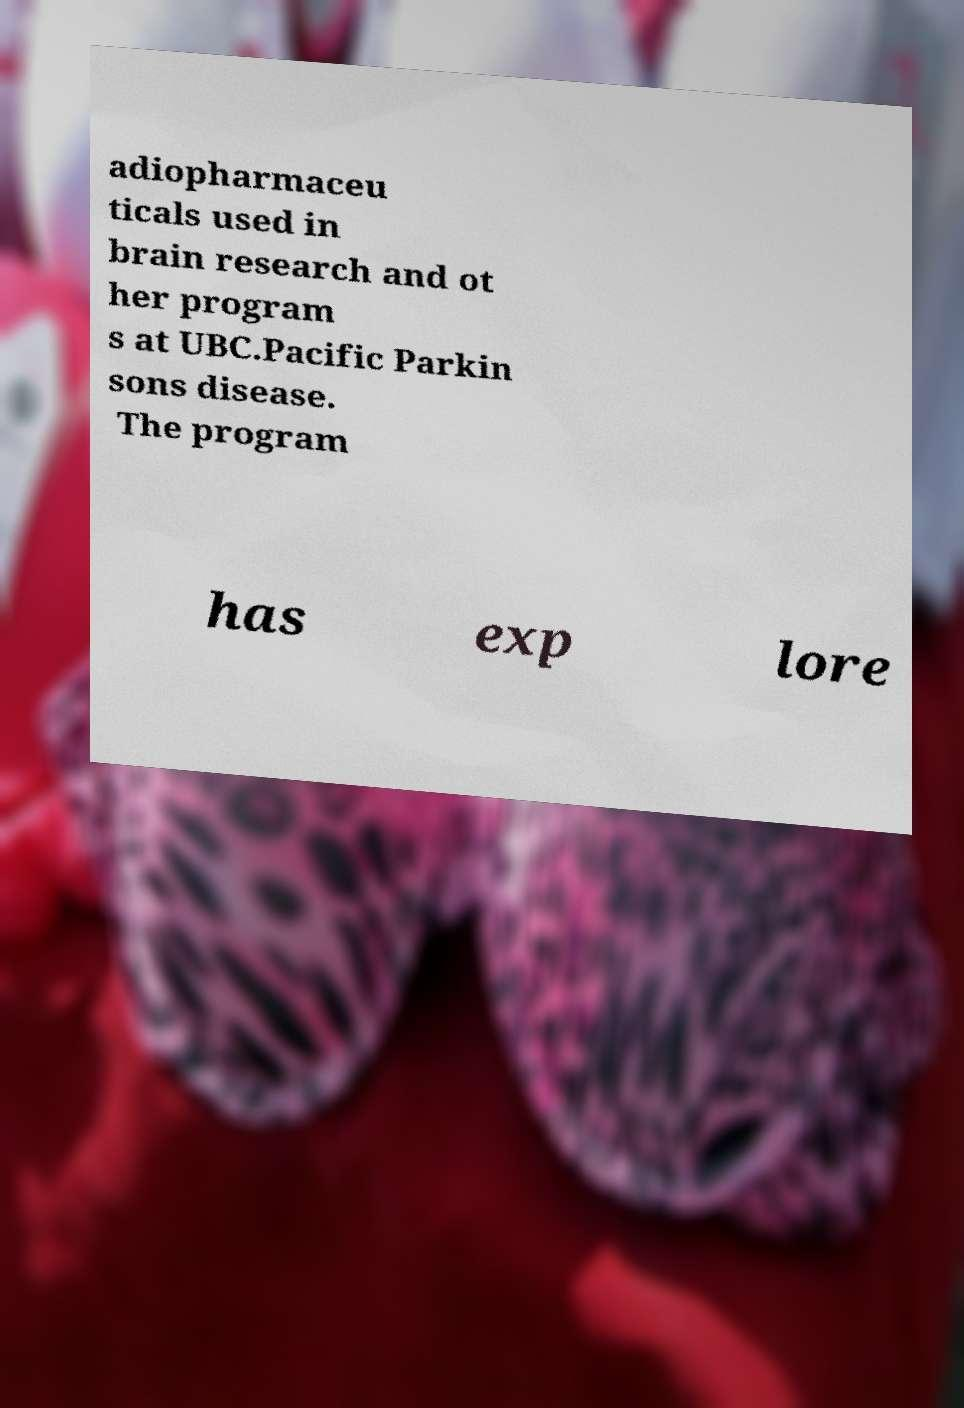There's text embedded in this image that I need extracted. Can you transcribe it verbatim? adiopharmaceu ticals used in brain research and ot her program s at UBC.Pacific Parkin sons disease. The program has exp lore 